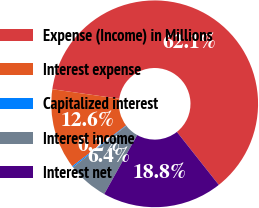<chart> <loc_0><loc_0><loc_500><loc_500><pie_chart><fcel>Expense (Income) in Millions<fcel>Interest expense<fcel>Capitalized interest<fcel>Interest income<fcel>Interest net<nl><fcel>62.09%<fcel>12.57%<fcel>0.19%<fcel>6.38%<fcel>18.76%<nl></chart> 